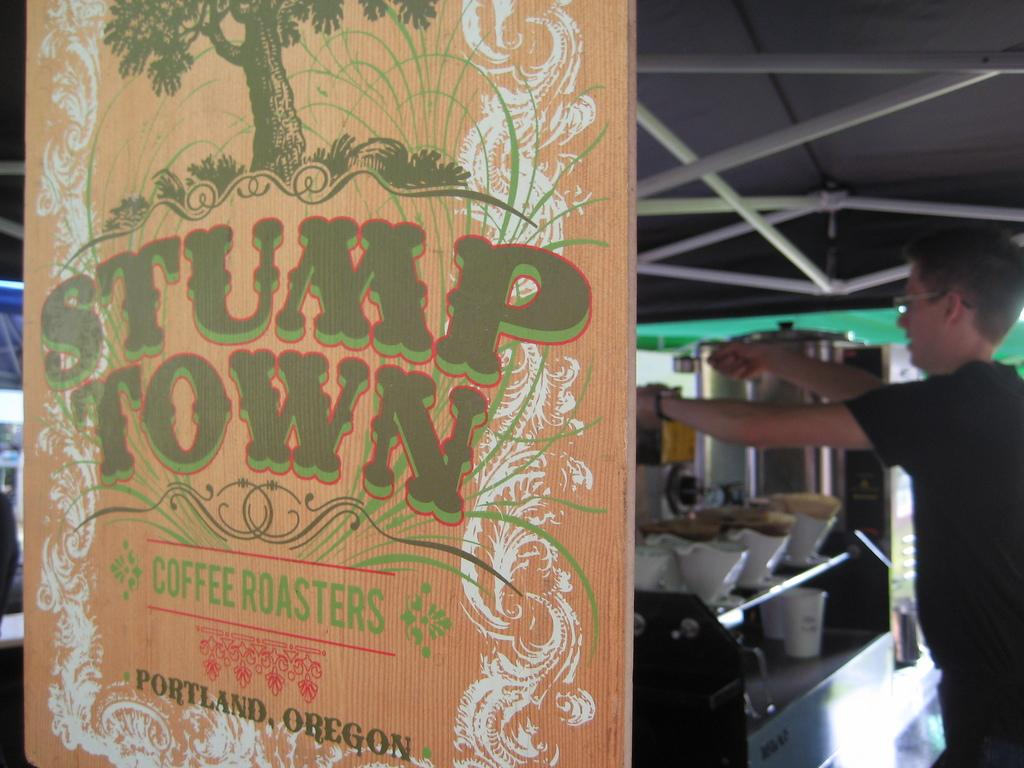<image>
Relay a brief, clear account of the picture shown. A man works behind a sign hanging in a window for Stump Town coffee roasters. 